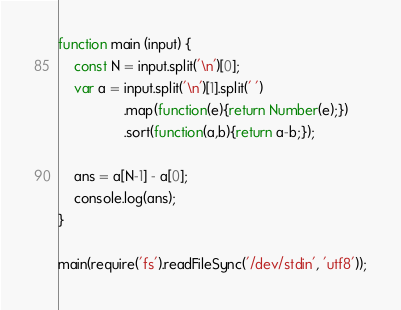Convert code to text. <code><loc_0><loc_0><loc_500><loc_500><_JavaScript_>function main (input) {
    const N = input.split('\n')[0];
    var a = input.split('\n')[1].split(' ')
                 .map(function(e){return Number(e);})
                 .sort(function(a,b){return a-b;});

    ans = a[N-1] - a[0];
    console.log(ans);
}

main(require('fs').readFileSync('/dev/stdin', 'utf8'));</code> 